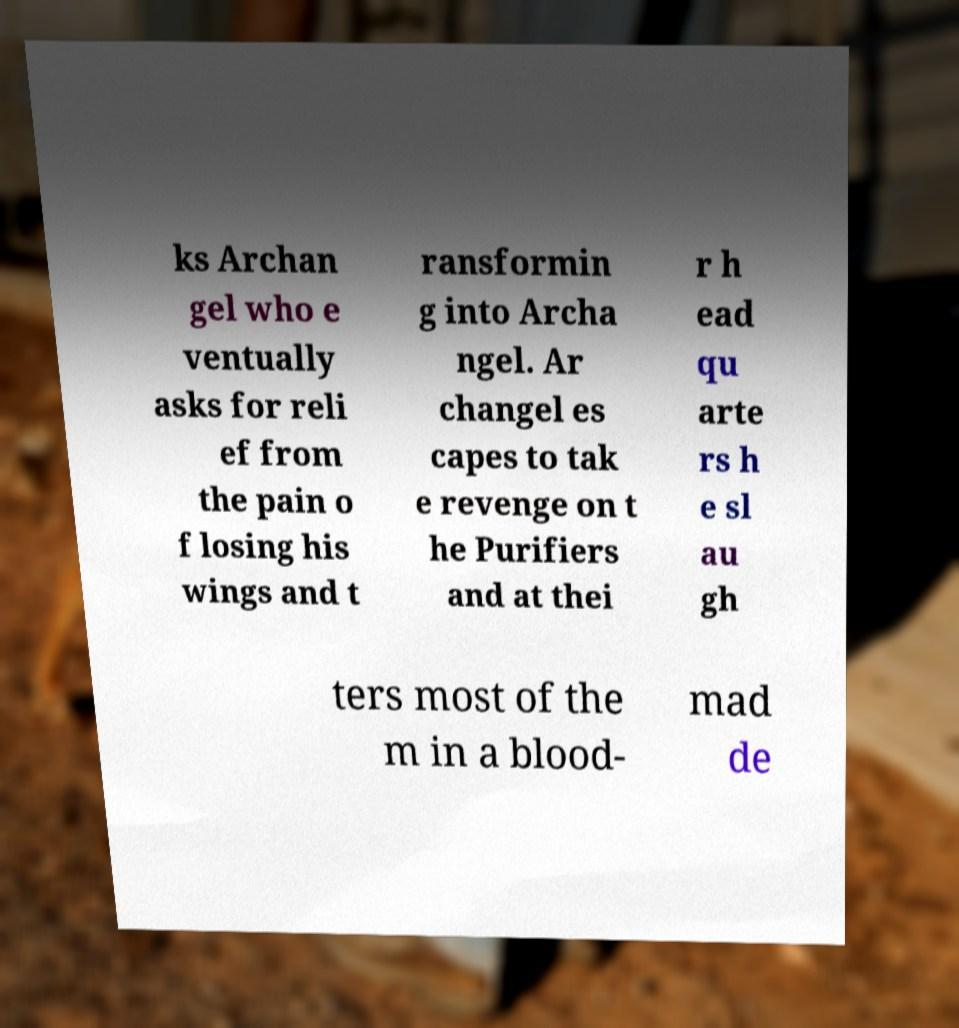Can you read and provide the text displayed in the image?This photo seems to have some interesting text. Can you extract and type it out for me? ks Archan gel who e ventually asks for reli ef from the pain o f losing his wings and t ransformin g into Archa ngel. Ar changel es capes to tak e revenge on t he Purifiers and at thei r h ead qu arte rs h e sl au gh ters most of the m in a blood- mad de 